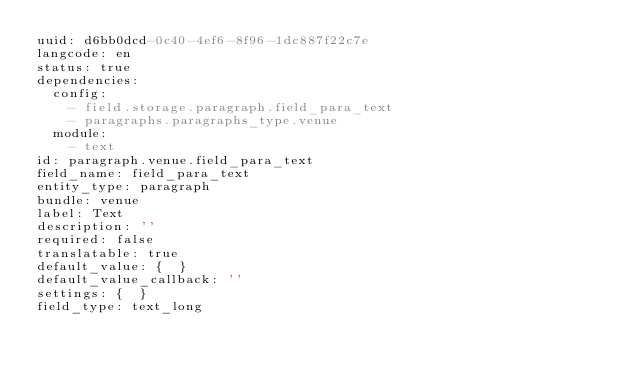<code> <loc_0><loc_0><loc_500><loc_500><_YAML_>uuid: d6bb0dcd-0c40-4ef6-8f96-1dc887f22c7e
langcode: en
status: true
dependencies:
  config:
    - field.storage.paragraph.field_para_text
    - paragraphs.paragraphs_type.venue
  module:
    - text
id: paragraph.venue.field_para_text
field_name: field_para_text
entity_type: paragraph
bundle: venue
label: Text
description: ''
required: false
translatable: true
default_value: {  }
default_value_callback: ''
settings: {  }
field_type: text_long
</code> 